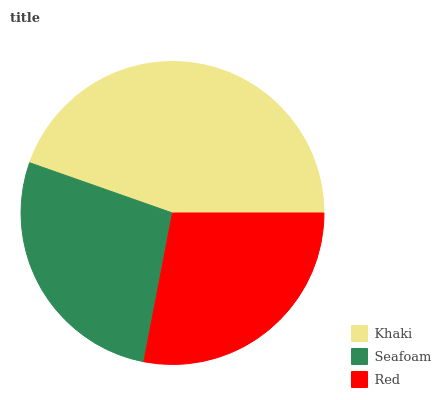Is Seafoam the minimum?
Answer yes or no. Yes. Is Khaki the maximum?
Answer yes or no. Yes. Is Red the minimum?
Answer yes or no. No. Is Red the maximum?
Answer yes or no. No. Is Red greater than Seafoam?
Answer yes or no. Yes. Is Seafoam less than Red?
Answer yes or no. Yes. Is Seafoam greater than Red?
Answer yes or no. No. Is Red less than Seafoam?
Answer yes or no. No. Is Red the high median?
Answer yes or no. Yes. Is Red the low median?
Answer yes or no. Yes. Is Khaki the high median?
Answer yes or no. No. Is Seafoam the low median?
Answer yes or no. No. 